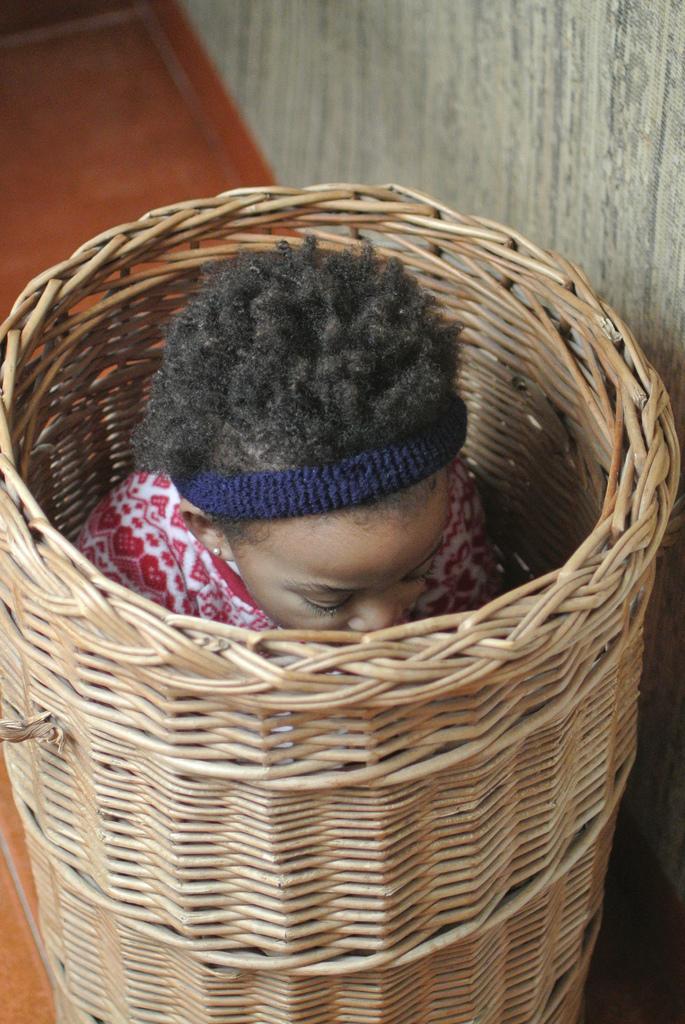Can you describe this image briefly? In this picture we can see one girl is sitting in the basket. 